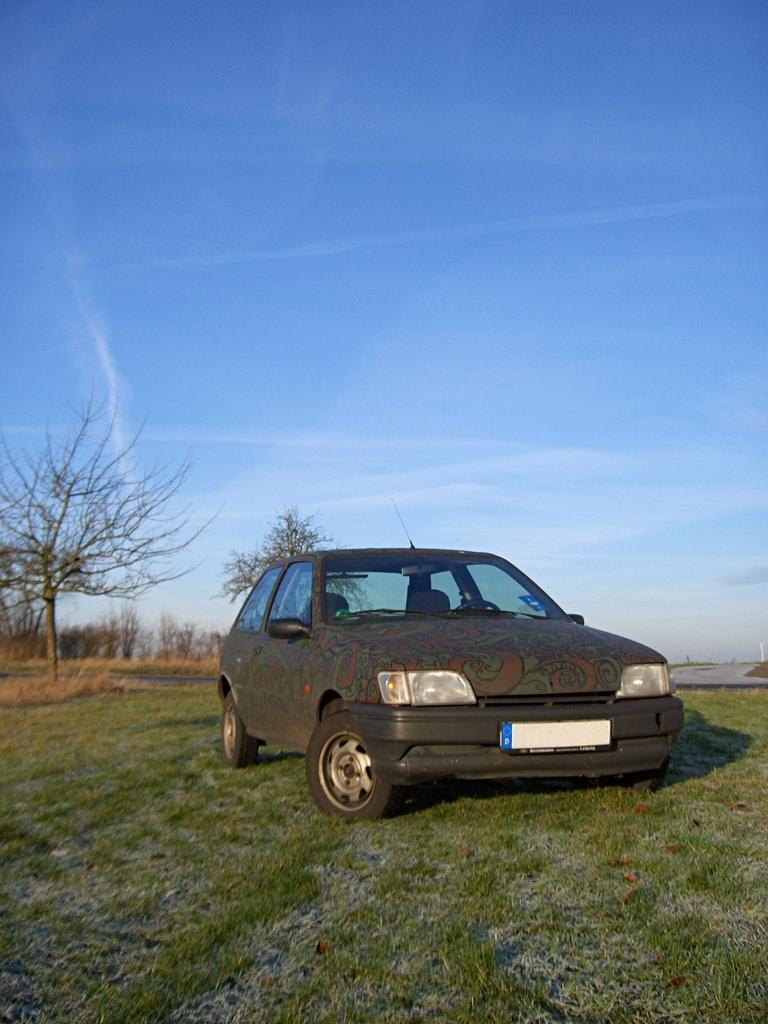What is the main subject in the foreground of the image? There is a car in the foreground of the image. What type of vegetation is present at the bottom of the image? There is green grass at the bottom of the image. What can be seen in the background of the image? There are trees and dry grass in the background of the image. What is visible at the top of the image? The sky is visible at the top of the image. What type of riddle is being solved in the office depicted in the image? There is no office or riddle present in the image; it features a car, green grass, trees, dry grass, and the sky. 